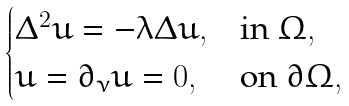Convert formula to latex. <formula><loc_0><loc_0><loc_500><loc_500>\begin{cases} \Delta ^ { 2 } u = - \lambda \Delta u , & \text {in } \Omega , \\ u = \partial _ { \nu } u = 0 , & \text {on } \partial \Omega , \end{cases}</formula> 